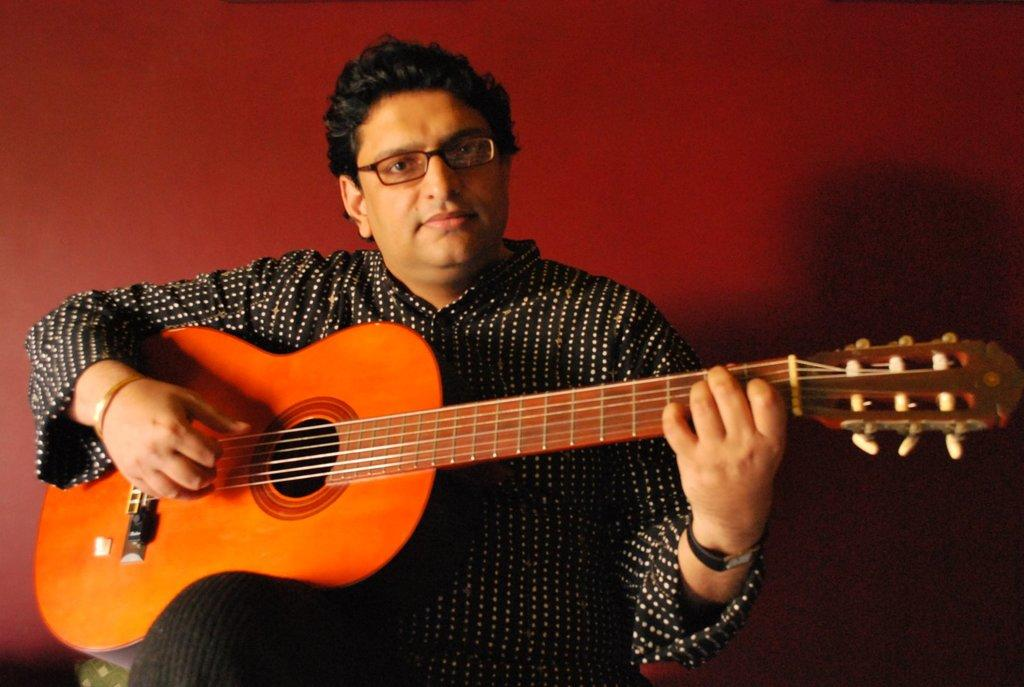What is the main subject of the image? The main subject of the image is a man. What is the man wearing in the image? The man is wearing spectacles in the image. What is the man holding in the image? The man is holding a guitar in the image. What is the man doing with the guitar? The man is playing the guitar in the image. What can be seen in the background of the image? There is a wall in the background of the image. What color is the wall in the image? The wall is painted red in the image. What type of cracker is the man eating in the image? There is no cracker present in the image; the man is playing a guitar. What part of the brain is the man using to play the guitar in the image? The image does not show the man's brain, so it is not possible to determine which part he is using to play the guitar. 